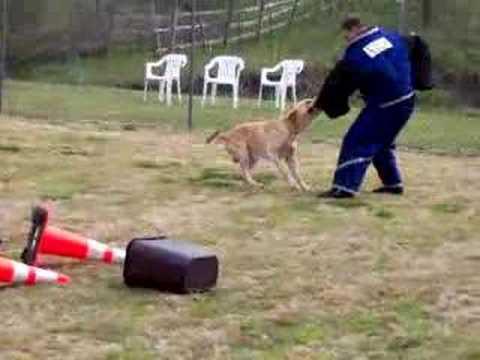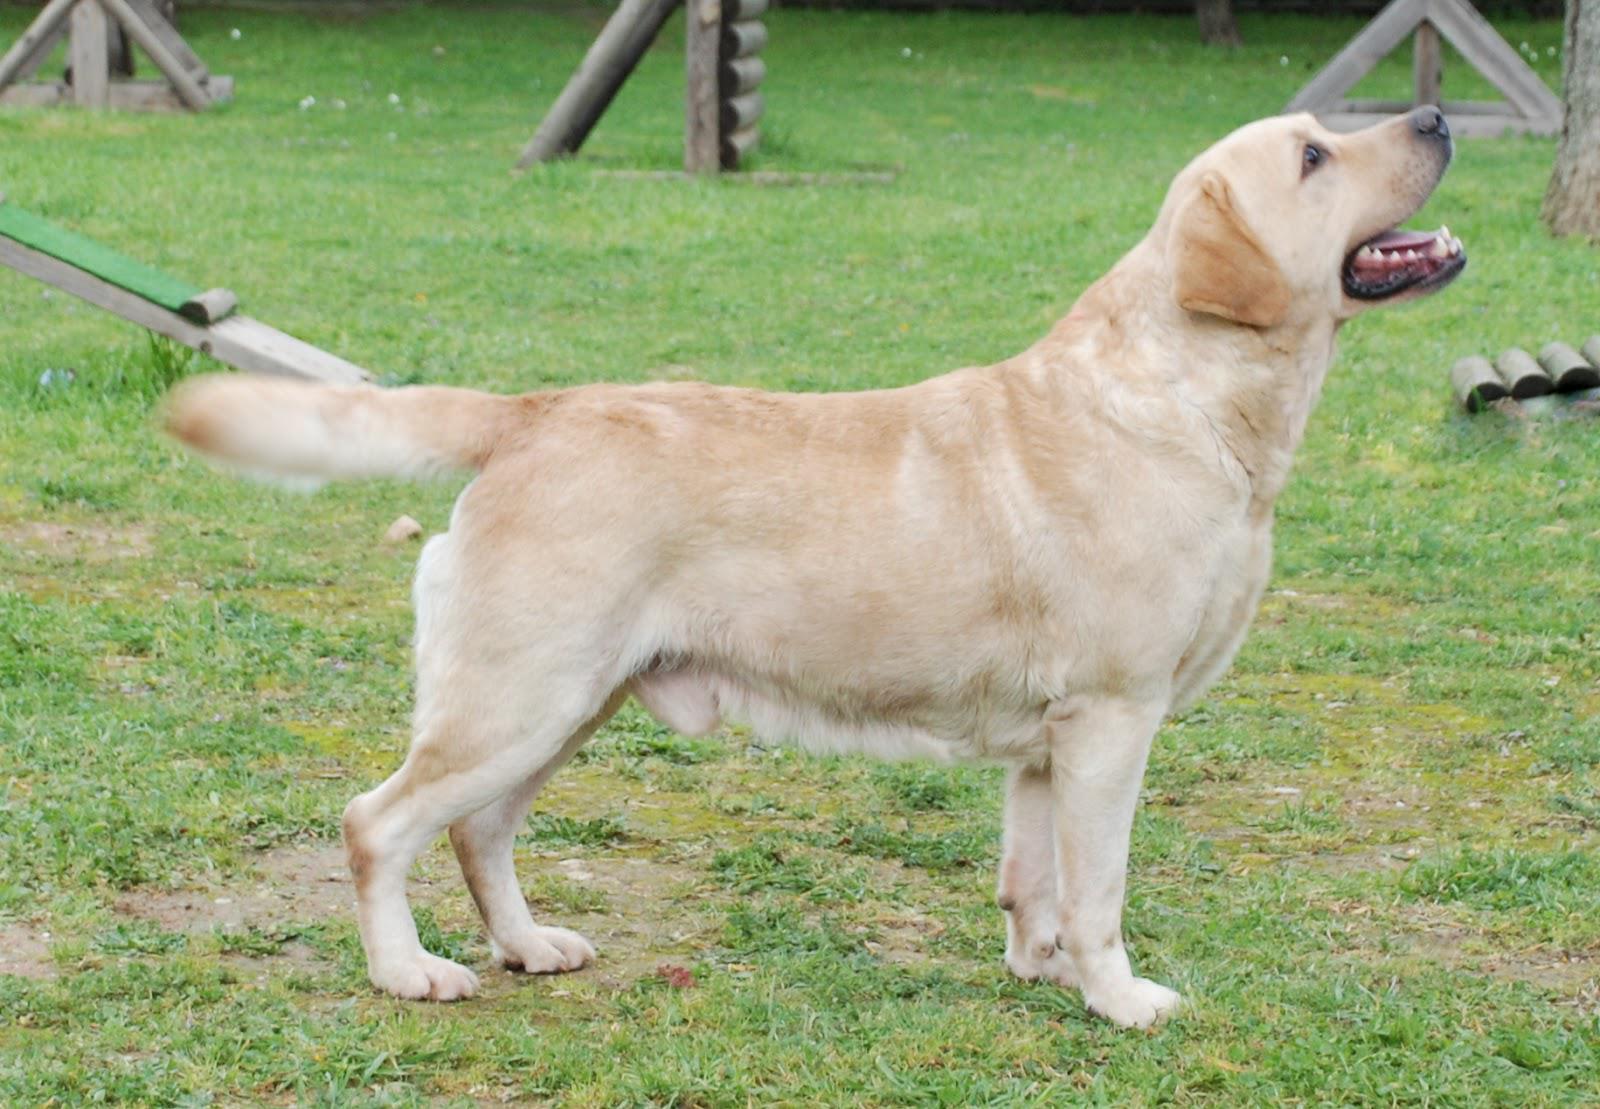The first image is the image on the left, the second image is the image on the right. Analyze the images presented: Is the assertion "A yellow dog is next to a woman." valid? Answer yes or no. No. The first image is the image on the left, the second image is the image on the right. Examine the images to the left and right. Is the description "There are no humans in the image on the right." accurate? Answer yes or no. Yes. 